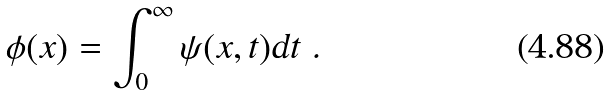<formula> <loc_0><loc_0><loc_500><loc_500>\phi ( x ) = \int _ { 0 } ^ { \infty } \psi ( x , t ) \text {d} t \text { .}</formula> 